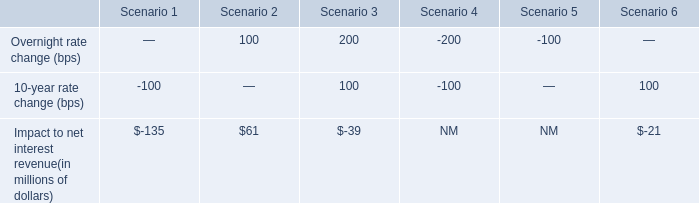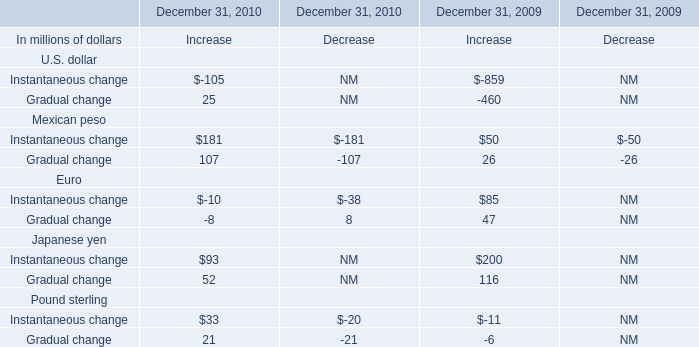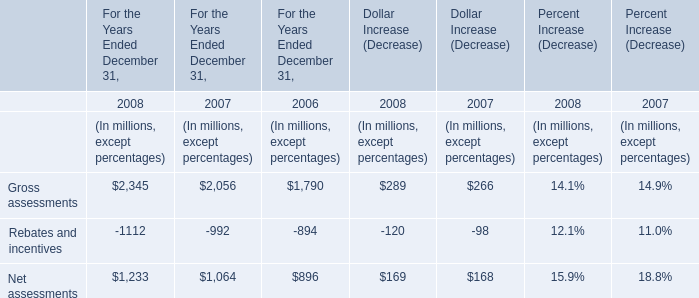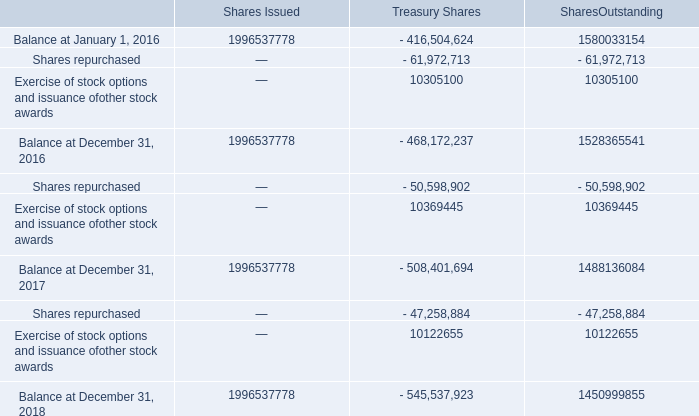In the year with largest amount of Gradual change for U.S. dollar, what's the increasing rate of Gradual change for U.S. dollar? 
Computations: ((25 + 460) / 25)
Answer: 19.4. 